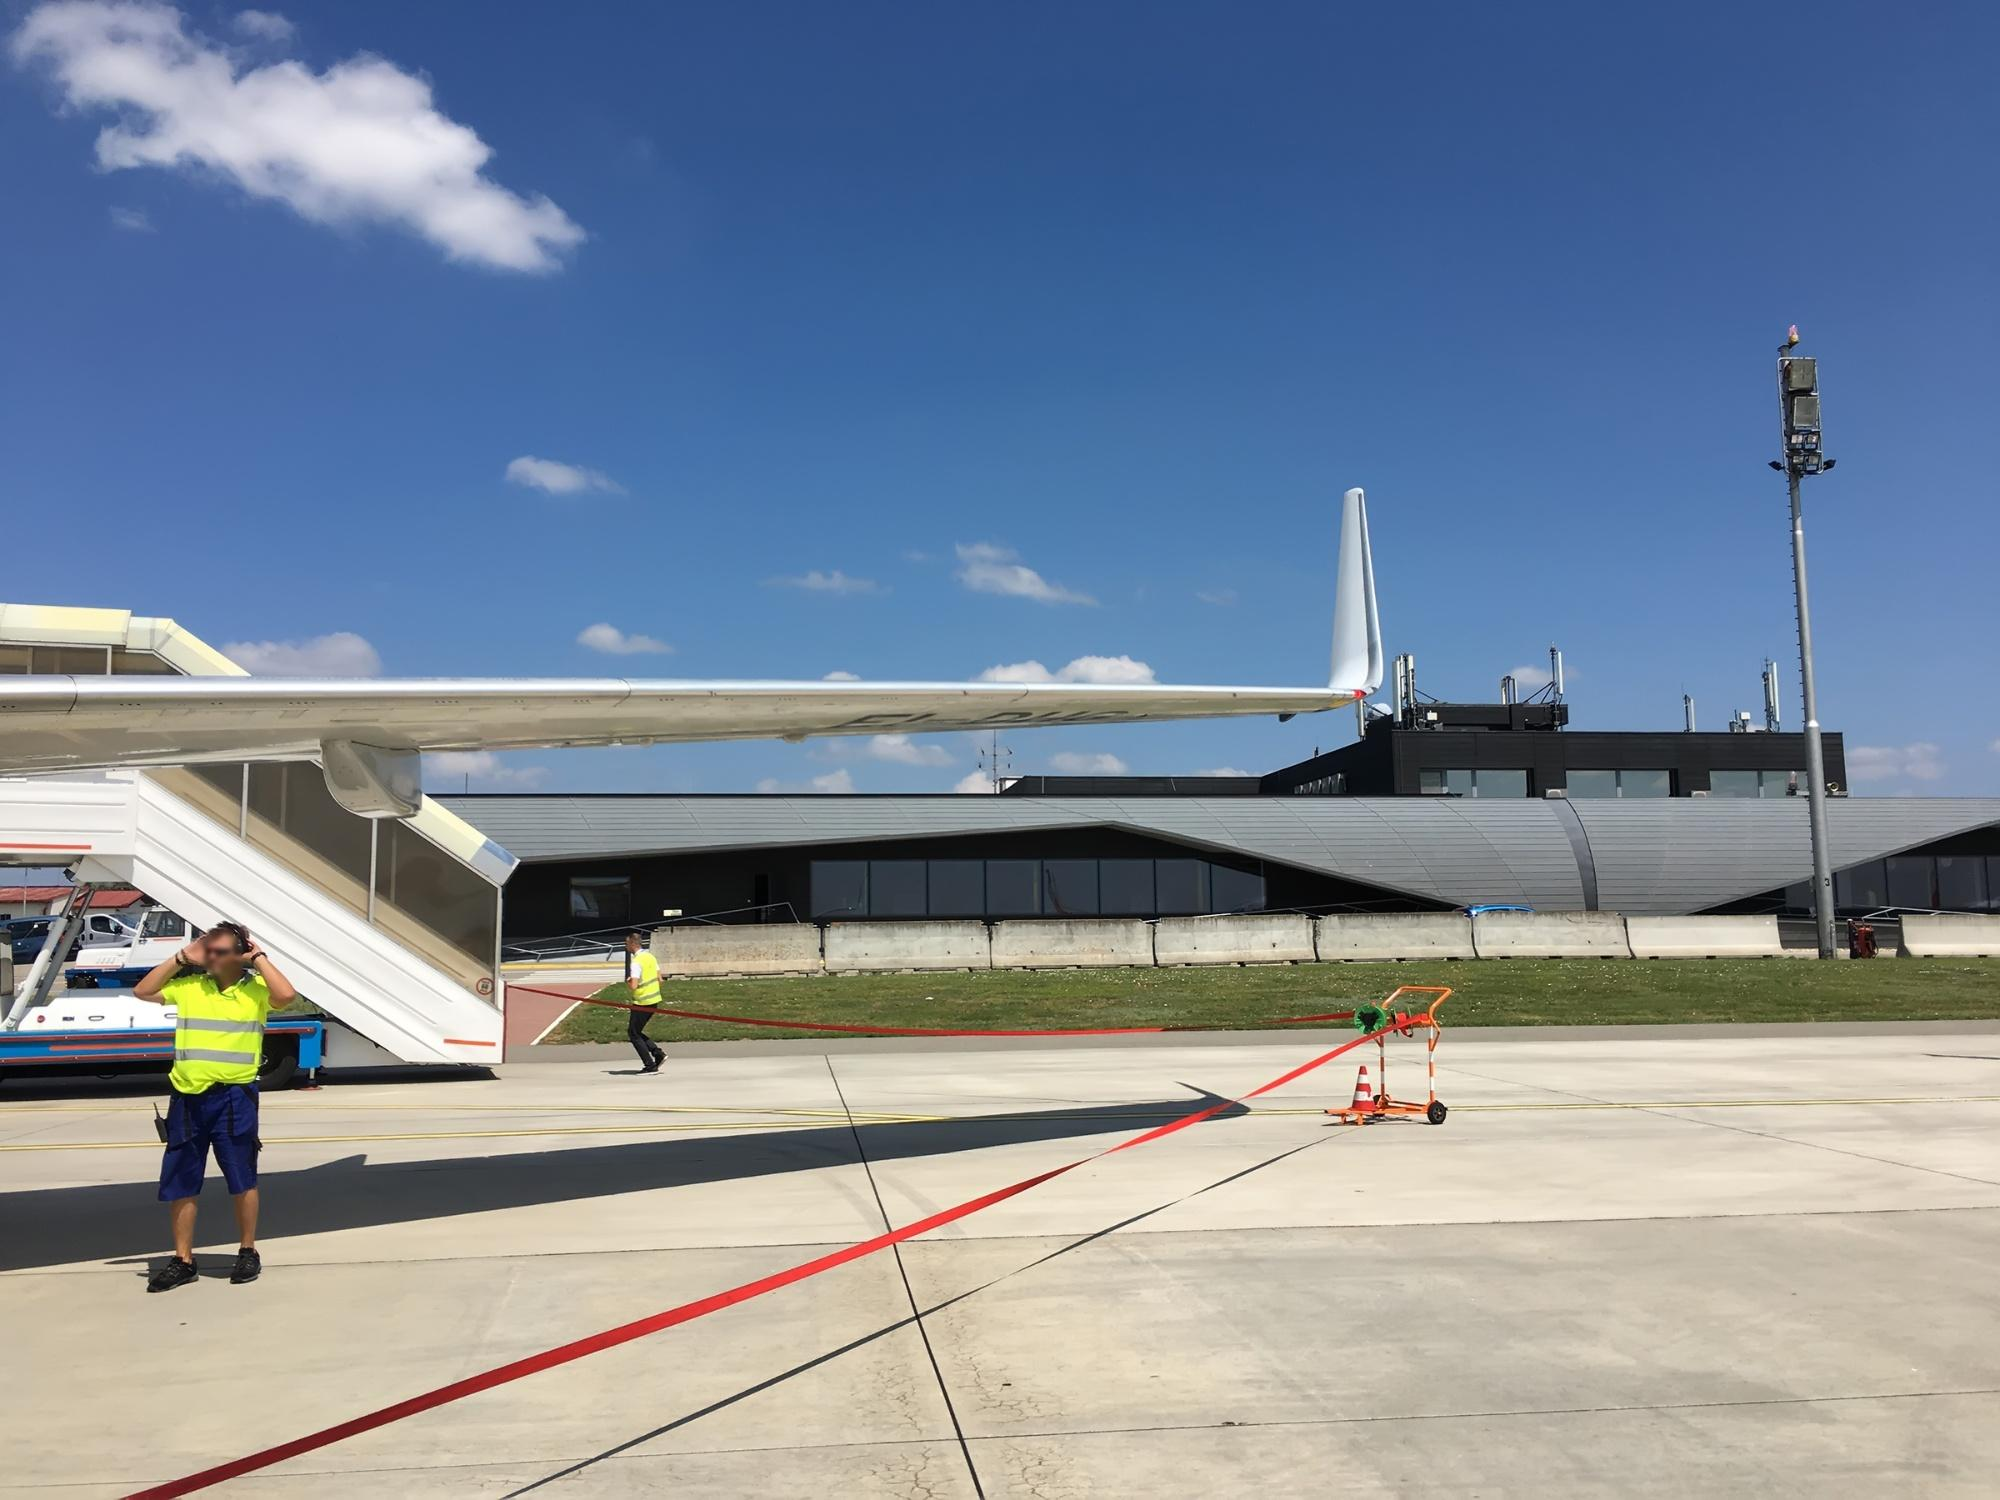Can you describe the terminal building in detail? Certainly! The terminal building in the background boasts a contemporary and streamlined design. It features an angular roofline that slopes down towards the edges, giving it a sleek and aerodynamic appearance that mirrors the planes it services. The facade is primarily composed of large, dark-tinted glass windows that provide a clear view into the building's interior while reflecting the bright sky and surroundings. The structure is divided into sections with clean, precise lines, suggesting a well-organized interior space. On the rooftop, various antennas and equipment hint at the building’s advanced communication systems, essential for the coordination of airport activities. The modern materials and architectural style of the terminal underscore the advanced infrastructure supporting today's air travel. What might be the role of the red ladder present in the image? The red ladder seen in the image is likely a piece of ground support equipment used for aircraft maintenance and operations. Its vibrant color ensures it is easily visible on the busy tarmac, enhancing safety by preventing accidental collisions. Such ladders are crucial for providing access to various parts of an aircraft that are high above the ground, such as inspecting the wings, engines, or other external components. This particular ladder appears mobile and sturdy, designed to be easily maneuvered and positioned as needed. Its presence indicates that maintenance activities or safety checks may be imminent, ensuring that the aircraft is in optimal condition for its next flight. If the airplane could talk, what do you think it would say about its day? If this airplane could talk, it might say: "Today is another exciting day at the airport! The sun is shining brightly, and I feel ready for a new adventure in the sky. The ground crew has been busy checking my systems, ensuring that every part is in perfect condition. I can feel the anticipation building as I await boarding, eager passengers soon to fill my cabin with their stories and dreams. The vast sky above calls to me, a reminder of the endless destinations and possibilities. Soon, I'll soar through the clouds, connecting people across the globe and living the journey I've been built for." 